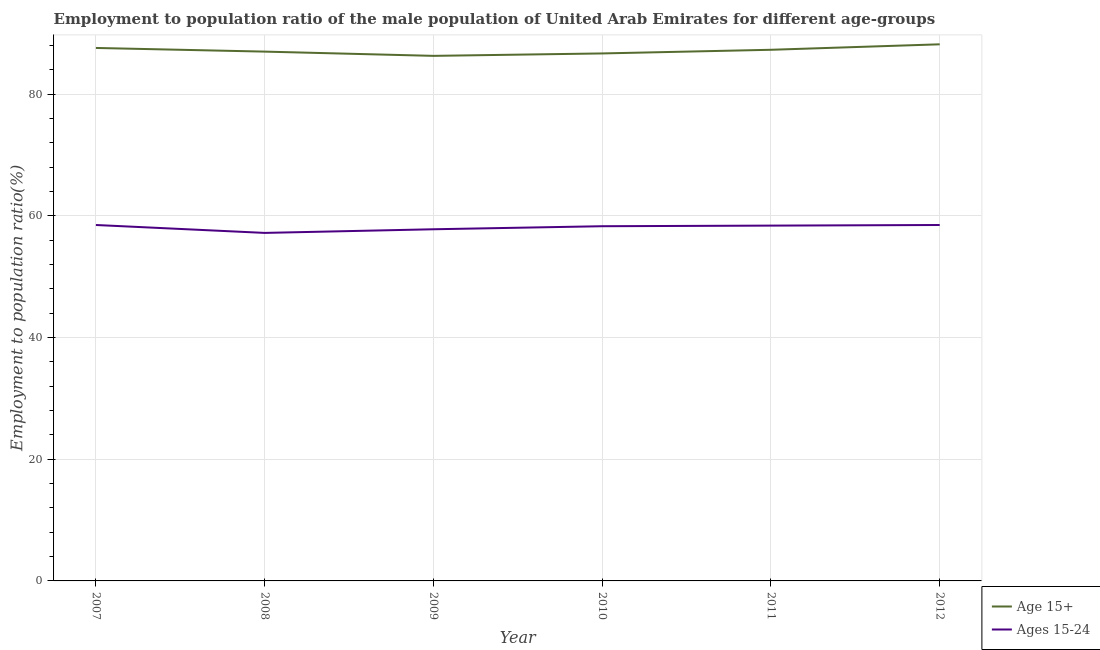Is the number of lines equal to the number of legend labels?
Provide a succinct answer. Yes. What is the employment to population ratio(age 15-24) in 2012?
Offer a very short reply. 58.5. Across all years, what is the maximum employment to population ratio(age 15+)?
Your answer should be compact. 88.2. Across all years, what is the minimum employment to population ratio(age 15-24)?
Ensure brevity in your answer.  57.2. In which year was the employment to population ratio(age 15+) minimum?
Keep it short and to the point. 2009. What is the total employment to population ratio(age 15+) in the graph?
Give a very brief answer. 523.1. What is the difference between the employment to population ratio(age 15+) in 2008 and that in 2011?
Offer a very short reply. -0.3. What is the difference between the employment to population ratio(age 15+) in 2011 and the employment to population ratio(age 15-24) in 2008?
Offer a very short reply. 30.1. What is the average employment to population ratio(age 15+) per year?
Provide a short and direct response. 87.18. In the year 2009, what is the difference between the employment to population ratio(age 15+) and employment to population ratio(age 15-24)?
Offer a terse response. 28.5. What is the ratio of the employment to population ratio(age 15-24) in 2007 to that in 2009?
Make the answer very short. 1.01. Is the difference between the employment to population ratio(age 15-24) in 2011 and 2012 greater than the difference between the employment to population ratio(age 15+) in 2011 and 2012?
Your response must be concise. Yes. What is the difference between the highest and the second highest employment to population ratio(age 15+)?
Make the answer very short. 0.6. What is the difference between the highest and the lowest employment to population ratio(age 15-24)?
Make the answer very short. 1.3. Is the employment to population ratio(age 15-24) strictly less than the employment to population ratio(age 15+) over the years?
Provide a succinct answer. Yes. Are the values on the major ticks of Y-axis written in scientific E-notation?
Offer a very short reply. No. Does the graph contain any zero values?
Provide a succinct answer. No. Does the graph contain grids?
Keep it short and to the point. Yes. How many legend labels are there?
Your response must be concise. 2. What is the title of the graph?
Your response must be concise. Employment to population ratio of the male population of United Arab Emirates for different age-groups. What is the Employment to population ratio(%) in Age 15+ in 2007?
Your answer should be compact. 87.6. What is the Employment to population ratio(%) in Ages 15-24 in 2007?
Offer a very short reply. 58.5. What is the Employment to population ratio(%) in Ages 15-24 in 2008?
Your answer should be compact. 57.2. What is the Employment to population ratio(%) of Age 15+ in 2009?
Give a very brief answer. 86.3. What is the Employment to population ratio(%) of Ages 15-24 in 2009?
Your response must be concise. 57.8. What is the Employment to population ratio(%) in Age 15+ in 2010?
Offer a terse response. 86.7. What is the Employment to population ratio(%) in Ages 15-24 in 2010?
Keep it short and to the point. 58.3. What is the Employment to population ratio(%) of Age 15+ in 2011?
Your response must be concise. 87.3. What is the Employment to population ratio(%) of Ages 15-24 in 2011?
Offer a terse response. 58.4. What is the Employment to population ratio(%) of Age 15+ in 2012?
Give a very brief answer. 88.2. What is the Employment to population ratio(%) of Ages 15-24 in 2012?
Your response must be concise. 58.5. Across all years, what is the maximum Employment to population ratio(%) of Age 15+?
Your answer should be very brief. 88.2. Across all years, what is the maximum Employment to population ratio(%) of Ages 15-24?
Ensure brevity in your answer.  58.5. Across all years, what is the minimum Employment to population ratio(%) of Age 15+?
Provide a succinct answer. 86.3. Across all years, what is the minimum Employment to population ratio(%) in Ages 15-24?
Provide a short and direct response. 57.2. What is the total Employment to population ratio(%) of Age 15+ in the graph?
Provide a succinct answer. 523.1. What is the total Employment to population ratio(%) of Ages 15-24 in the graph?
Provide a succinct answer. 348.7. What is the difference between the Employment to population ratio(%) of Age 15+ in 2007 and that in 2008?
Keep it short and to the point. 0.6. What is the difference between the Employment to population ratio(%) of Ages 15-24 in 2007 and that in 2009?
Ensure brevity in your answer.  0.7. What is the difference between the Employment to population ratio(%) in Age 15+ in 2007 and that in 2010?
Provide a short and direct response. 0.9. What is the difference between the Employment to population ratio(%) in Ages 15-24 in 2007 and that in 2010?
Ensure brevity in your answer.  0.2. What is the difference between the Employment to population ratio(%) of Ages 15-24 in 2007 and that in 2011?
Keep it short and to the point. 0.1. What is the difference between the Employment to population ratio(%) of Ages 15-24 in 2007 and that in 2012?
Your answer should be compact. 0. What is the difference between the Employment to population ratio(%) in Age 15+ in 2008 and that in 2009?
Provide a succinct answer. 0.7. What is the difference between the Employment to population ratio(%) of Age 15+ in 2008 and that in 2010?
Your response must be concise. 0.3. What is the difference between the Employment to population ratio(%) of Ages 15-24 in 2008 and that in 2010?
Offer a terse response. -1.1. What is the difference between the Employment to population ratio(%) in Ages 15-24 in 2008 and that in 2011?
Your response must be concise. -1.2. What is the difference between the Employment to population ratio(%) in Age 15+ in 2008 and that in 2012?
Your answer should be compact. -1.2. What is the difference between the Employment to population ratio(%) of Ages 15-24 in 2008 and that in 2012?
Provide a short and direct response. -1.3. What is the difference between the Employment to population ratio(%) of Age 15+ in 2009 and that in 2010?
Ensure brevity in your answer.  -0.4. What is the difference between the Employment to population ratio(%) of Age 15+ in 2009 and that in 2011?
Give a very brief answer. -1. What is the difference between the Employment to population ratio(%) in Ages 15-24 in 2009 and that in 2011?
Your response must be concise. -0.6. What is the difference between the Employment to population ratio(%) in Age 15+ in 2009 and that in 2012?
Your answer should be very brief. -1.9. What is the difference between the Employment to population ratio(%) in Ages 15-24 in 2010 and that in 2011?
Offer a terse response. -0.1. What is the difference between the Employment to population ratio(%) in Age 15+ in 2011 and that in 2012?
Make the answer very short. -0.9. What is the difference between the Employment to population ratio(%) of Ages 15-24 in 2011 and that in 2012?
Offer a very short reply. -0.1. What is the difference between the Employment to population ratio(%) of Age 15+ in 2007 and the Employment to population ratio(%) of Ages 15-24 in 2008?
Provide a short and direct response. 30.4. What is the difference between the Employment to population ratio(%) in Age 15+ in 2007 and the Employment to population ratio(%) in Ages 15-24 in 2009?
Provide a short and direct response. 29.8. What is the difference between the Employment to population ratio(%) of Age 15+ in 2007 and the Employment to population ratio(%) of Ages 15-24 in 2010?
Ensure brevity in your answer.  29.3. What is the difference between the Employment to population ratio(%) in Age 15+ in 2007 and the Employment to population ratio(%) in Ages 15-24 in 2011?
Keep it short and to the point. 29.2. What is the difference between the Employment to population ratio(%) of Age 15+ in 2007 and the Employment to population ratio(%) of Ages 15-24 in 2012?
Offer a very short reply. 29.1. What is the difference between the Employment to population ratio(%) of Age 15+ in 2008 and the Employment to population ratio(%) of Ages 15-24 in 2009?
Give a very brief answer. 29.2. What is the difference between the Employment to population ratio(%) of Age 15+ in 2008 and the Employment to population ratio(%) of Ages 15-24 in 2010?
Provide a succinct answer. 28.7. What is the difference between the Employment to population ratio(%) of Age 15+ in 2008 and the Employment to population ratio(%) of Ages 15-24 in 2011?
Provide a succinct answer. 28.6. What is the difference between the Employment to population ratio(%) in Age 15+ in 2009 and the Employment to population ratio(%) in Ages 15-24 in 2010?
Ensure brevity in your answer.  28. What is the difference between the Employment to population ratio(%) of Age 15+ in 2009 and the Employment to population ratio(%) of Ages 15-24 in 2011?
Your response must be concise. 27.9. What is the difference between the Employment to population ratio(%) of Age 15+ in 2009 and the Employment to population ratio(%) of Ages 15-24 in 2012?
Provide a short and direct response. 27.8. What is the difference between the Employment to population ratio(%) in Age 15+ in 2010 and the Employment to population ratio(%) in Ages 15-24 in 2011?
Your answer should be very brief. 28.3. What is the difference between the Employment to population ratio(%) of Age 15+ in 2010 and the Employment to population ratio(%) of Ages 15-24 in 2012?
Give a very brief answer. 28.2. What is the difference between the Employment to population ratio(%) of Age 15+ in 2011 and the Employment to population ratio(%) of Ages 15-24 in 2012?
Provide a short and direct response. 28.8. What is the average Employment to population ratio(%) of Age 15+ per year?
Provide a short and direct response. 87.18. What is the average Employment to population ratio(%) in Ages 15-24 per year?
Your answer should be very brief. 58.12. In the year 2007, what is the difference between the Employment to population ratio(%) in Age 15+ and Employment to population ratio(%) in Ages 15-24?
Provide a succinct answer. 29.1. In the year 2008, what is the difference between the Employment to population ratio(%) of Age 15+ and Employment to population ratio(%) of Ages 15-24?
Keep it short and to the point. 29.8. In the year 2009, what is the difference between the Employment to population ratio(%) in Age 15+ and Employment to population ratio(%) in Ages 15-24?
Your response must be concise. 28.5. In the year 2010, what is the difference between the Employment to population ratio(%) of Age 15+ and Employment to population ratio(%) of Ages 15-24?
Offer a terse response. 28.4. In the year 2011, what is the difference between the Employment to population ratio(%) in Age 15+ and Employment to population ratio(%) in Ages 15-24?
Offer a terse response. 28.9. In the year 2012, what is the difference between the Employment to population ratio(%) in Age 15+ and Employment to population ratio(%) in Ages 15-24?
Provide a succinct answer. 29.7. What is the ratio of the Employment to population ratio(%) of Age 15+ in 2007 to that in 2008?
Ensure brevity in your answer.  1.01. What is the ratio of the Employment to population ratio(%) of Ages 15-24 in 2007 to that in 2008?
Offer a terse response. 1.02. What is the ratio of the Employment to population ratio(%) of Age 15+ in 2007 to that in 2009?
Ensure brevity in your answer.  1.02. What is the ratio of the Employment to population ratio(%) in Ages 15-24 in 2007 to that in 2009?
Offer a very short reply. 1.01. What is the ratio of the Employment to population ratio(%) in Age 15+ in 2007 to that in 2010?
Keep it short and to the point. 1.01. What is the ratio of the Employment to population ratio(%) in Ages 15-24 in 2007 to that in 2010?
Give a very brief answer. 1. What is the ratio of the Employment to population ratio(%) in Age 15+ in 2007 to that in 2011?
Your answer should be compact. 1. What is the ratio of the Employment to population ratio(%) of Ages 15-24 in 2007 to that in 2011?
Ensure brevity in your answer.  1. What is the ratio of the Employment to population ratio(%) of Age 15+ in 2007 to that in 2012?
Keep it short and to the point. 0.99. What is the ratio of the Employment to population ratio(%) in Ages 15-24 in 2008 to that in 2009?
Your answer should be compact. 0.99. What is the ratio of the Employment to population ratio(%) in Ages 15-24 in 2008 to that in 2010?
Provide a succinct answer. 0.98. What is the ratio of the Employment to population ratio(%) in Ages 15-24 in 2008 to that in 2011?
Offer a terse response. 0.98. What is the ratio of the Employment to population ratio(%) in Age 15+ in 2008 to that in 2012?
Keep it short and to the point. 0.99. What is the ratio of the Employment to population ratio(%) in Ages 15-24 in 2008 to that in 2012?
Your response must be concise. 0.98. What is the ratio of the Employment to population ratio(%) in Age 15+ in 2009 to that in 2010?
Ensure brevity in your answer.  1. What is the ratio of the Employment to population ratio(%) of Ages 15-24 in 2009 to that in 2010?
Your answer should be very brief. 0.99. What is the ratio of the Employment to population ratio(%) in Ages 15-24 in 2009 to that in 2011?
Provide a succinct answer. 0.99. What is the ratio of the Employment to population ratio(%) of Age 15+ in 2009 to that in 2012?
Offer a very short reply. 0.98. What is the ratio of the Employment to population ratio(%) in Ages 15-24 in 2009 to that in 2012?
Provide a short and direct response. 0.99. What is the ratio of the Employment to population ratio(%) of Age 15+ in 2010 to that in 2011?
Provide a succinct answer. 0.99. What is the ratio of the Employment to population ratio(%) of Ages 15-24 in 2010 to that in 2012?
Give a very brief answer. 1. What is the difference between the highest and the second highest Employment to population ratio(%) in Age 15+?
Provide a short and direct response. 0.6. What is the difference between the highest and the lowest Employment to population ratio(%) in Age 15+?
Your response must be concise. 1.9. 